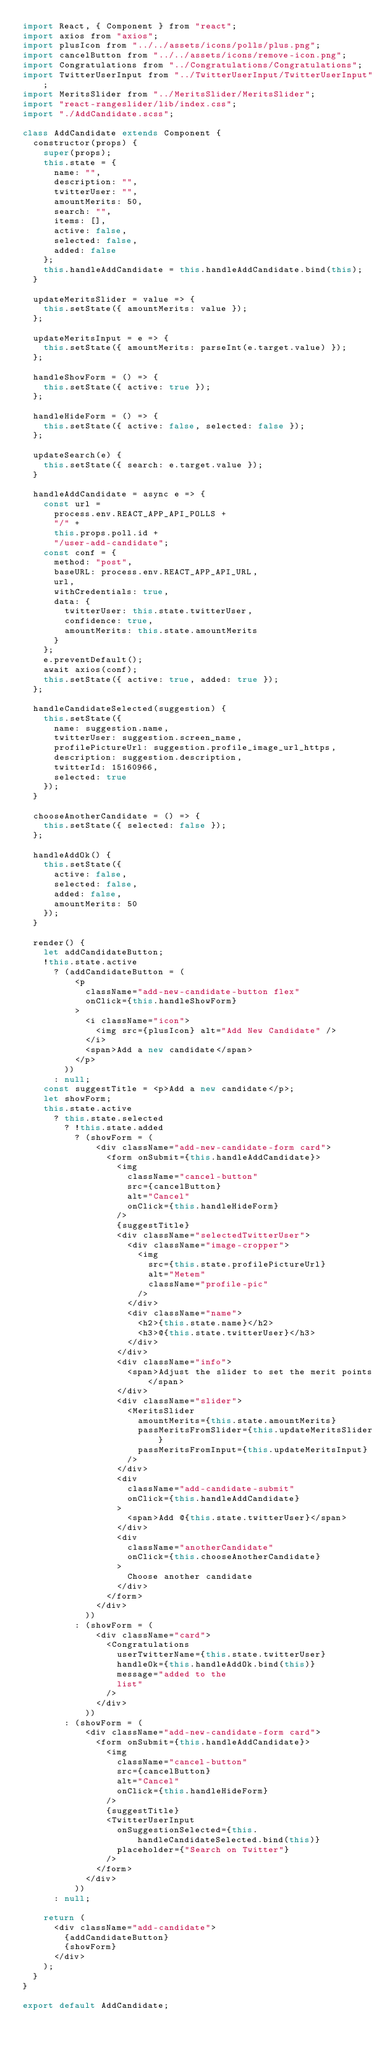Convert code to text. <code><loc_0><loc_0><loc_500><loc_500><_JavaScript_>import React, { Component } from "react";
import axios from "axios";
import plusIcon from "../../assets/icons/polls/plus.png";
import cancelButton from "../../assets/icons/remove-icon.png";
import Congratulations from "../Congratulations/Congratulations";
import TwitterUserInput from "../TwitterUserInput/TwitterUserInput";
import MeritsSlider from "../MeritsSlider/MeritsSlider";
import "react-rangeslider/lib/index.css";
import "./AddCandidate.scss";

class AddCandidate extends Component {
  constructor(props) {
    super(props);
    this.state = {
      name: "",
      description: "",
      twitterUser: "",
      amountMerits: 50,
      search: "",
      items: [],
      active: false,
      selected: false,
      added: false
    };
    this.handleAddCandidate = this.handleAddCandidate.bind(this);
  }

  updateMeritsSlider = value => {
    this.setState({ amountMerits: value });
  };

  updateMeritsInput = e => {
    this.setState({ amountMerits: parseInt(e.target.value) });
  };

  handleShowForm = () => {
    this.setState({ active: true });
  };

  handleHideForm = () => {
    this.setState({ active: false, selected: false });
  };

  updateSearch(e) {
    this.setState({ search: e.target.value });
  }

  handleAddCandidate = async e => {
    const url =
      process.env.REACT_APP_API_POLLS +
      "/" +
      this.props.poll.id +
      "/user-add-candidate";
    const conf = {
      method: "post",
      baseURL: process.env.REACT_APP_API_URL,
      url,
      withCredentials: true,
      data: {
        twitterUser: this.state.twitterUser,
        confidence: true,
        amountMerits: this.state.amountMerits
      }
    };
    e.preventDefault();
    await axios(conf);
    this.setState({ active: true, added: true });
  };

  handleCandidateSelected(suggestion) {
    this.setState({
      name: suggestion.name,
      twitterUser: suggestion.screen_name,
      profilePictureUrl: suggestion.profile_image_url_https,
      description: suggestion.description,
      twitterId: 15160966,
      selected: true
    });
  }

  chooseAnotherCandidate = () => {
    this.setState({ selected: false });
  };

  handleAddOk() {
    this.setState({
      active: false,
      selected: false,
      added: false,
      amountMerits: 50
    });
  }

  render() {
    let addCandidateButton;
    !this.state.active
      ? (addCandidateButton = (
          <p
            className="add-new-candidate-button flex"
            onClick={this.handleShowForm}
          >
            <i className="icon">
              <img src={plusIcon} alt="Add New Candidate" />
            </i>
            <span>Add a new candidate</span>
          </p>
        ))
      : null;
    const suggestTitle = <p>Add a new candidate</p>;
    let showForm;
    this.state.active
      ? this.state.selected
        ? !this.state.added
          ? (showForm = (
              <div className="add-new-candidate-form card">
                <form onSubmit={this.handleAddCandidate}>
                  <img
                    className="cancel-button"
                    src={cancelButton}
                    alt="Cancel"
                    onClick={this.handleHideForm}
                  />
                  {suggestTitle}
                  <div className="selectedTwitterUser">
                    <div className="image-cropper">
                      <img
                        src={this.state.profilePictureUrl}
                        alt="Metem"
                        className="profile-pic"
                      />
                    </div>
                    <div className="name">
                      <h2>{this.state.name}</h2>
                      <h3>@{this.state.twitterUser}</h3>
                    </div>
                  </div>
                  <div className="info">
                    <span>Adjust the slider to set the merit points</span>
                  </div>
                  <div className="slider">
                    <MeritsSlider
                      amountMerits={this.state.amountMerits}
                      passMeritsFromSlider={this.updateMeritsSlider}
                      passMeritsFromInput={this.updateMeritsInput}
                    />
                  </div>
                  <div
                    className="add-candidate-submit"
                    onClick={this.handleAddCandidate}
                  >
                    <span>Add @{this.state.twitterUser}</span>
                  </div>
                  <div
                    className="anotherCandidate"
                    onClick={this.chooseAnotherCandidate}
                  >
                    Choose another candidate
                  </div>
                </form>
              </div>
            ))
          : (showForm = (
              <div className="card">
                <Congratulations
                  userTwitterName={this.state.twitterUser}
                  handleOk={this.handleAddOk.bind(this)}
                  message="added to the
                  list"
                />
              </div>
            ))
        : (showForm = (
            <div className="add-new-candidate-form card">
              <form onSubmit={this.handleAddCandidate}>
                <img
                  className="cancel-button"
                  src={cancelButton}
                  alt="Cancel"
                  onClick={this.handleHideForm}
                />
                {suggestTitle}
                <TwitterUserInput
                  onSuggestionSelected={this.handleCandidateSelected.bind(this)}
                  placeholder={"Search on Twitter"}
                />
              </form>
            </div>
          ))
      : null;

    return (
      <div className="add-candidate">
        {addCandidateButton}
        {showForm}
      </div>
    );
  }
}

export default AddCandidate;
</code> 